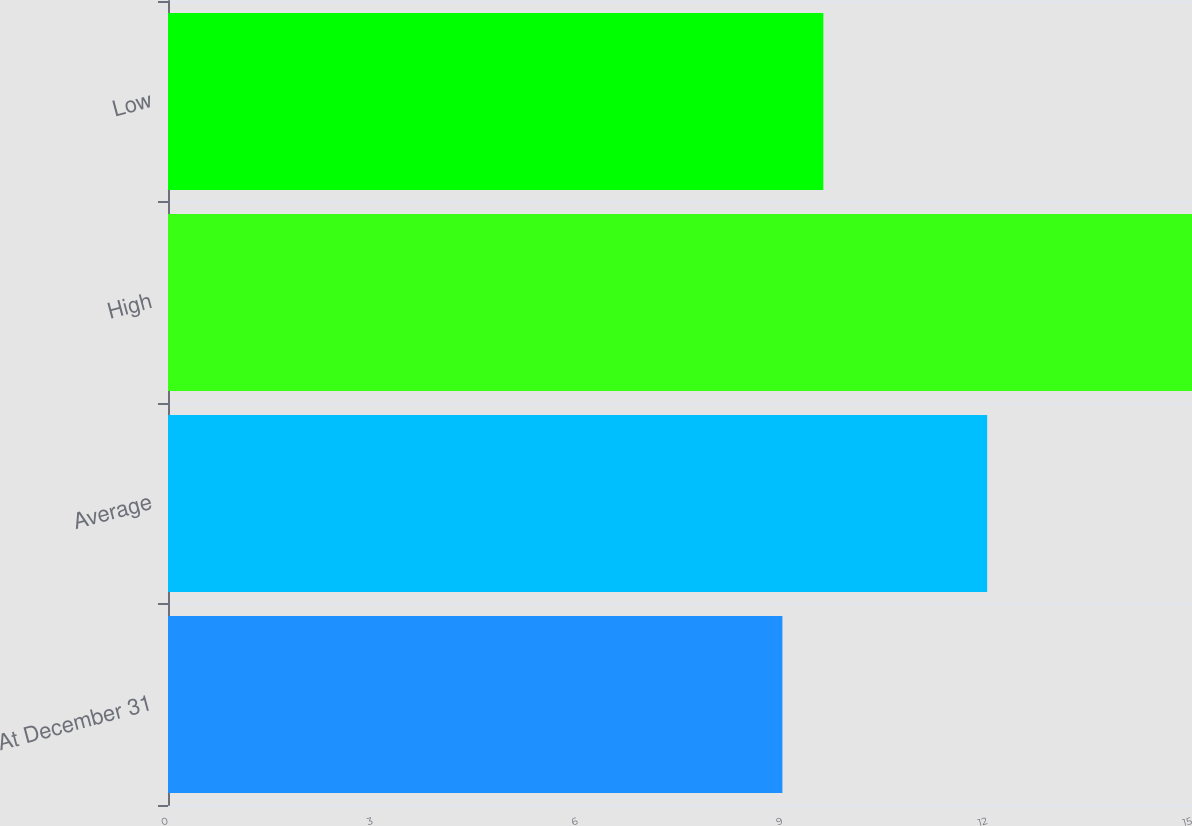Convert chart. <chart><loc_0><loc_0><loc_500><loc_500><bar_chart><fcel>At December 31<fcel>Average<fcel>High<fcel>Low<nl><fcel>9<fcel>12<fcel>15<fcel>9.6<nl></chart> 